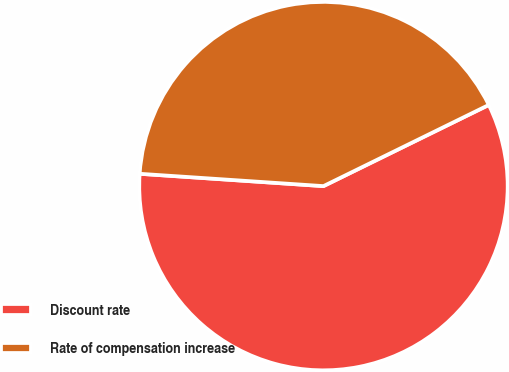<chart> <loc_0><loc_0><loc_500><loc_500><pie_chart><fcel>Discount rate<fcel>Rate of compensation increase<nl><fcel>58.33%<fcel>41.67%<nl></chart> 